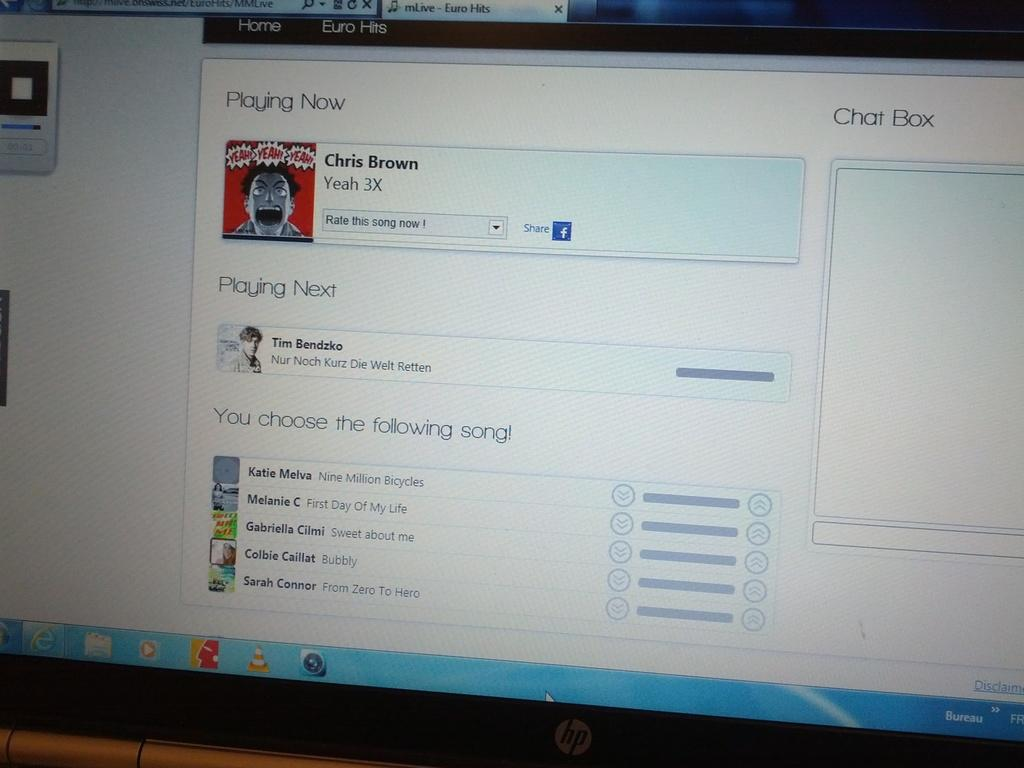<image>
Give a short and clear explanation of the subsequent image. A screen showing that Yeah 3X by Chris Brown is playing now. 